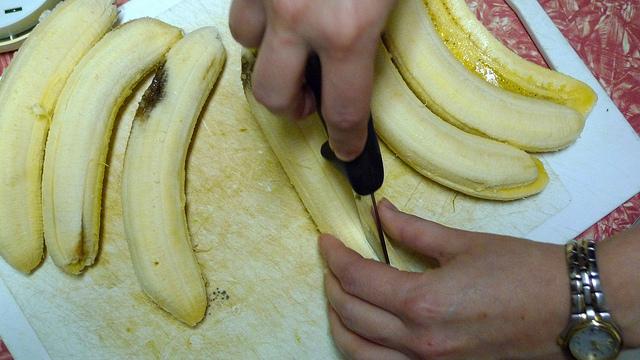What is placed on the chopping board?
Be succinct. Bananas. How many bananas are bruised?
Write a very short answer. 2. Is this meal healthy?
Be succinct. Yes. What object in the photo tells you the time?
Give a very brief answer. Watch. What color are the bananas?
Quick response, please. Yellow. 